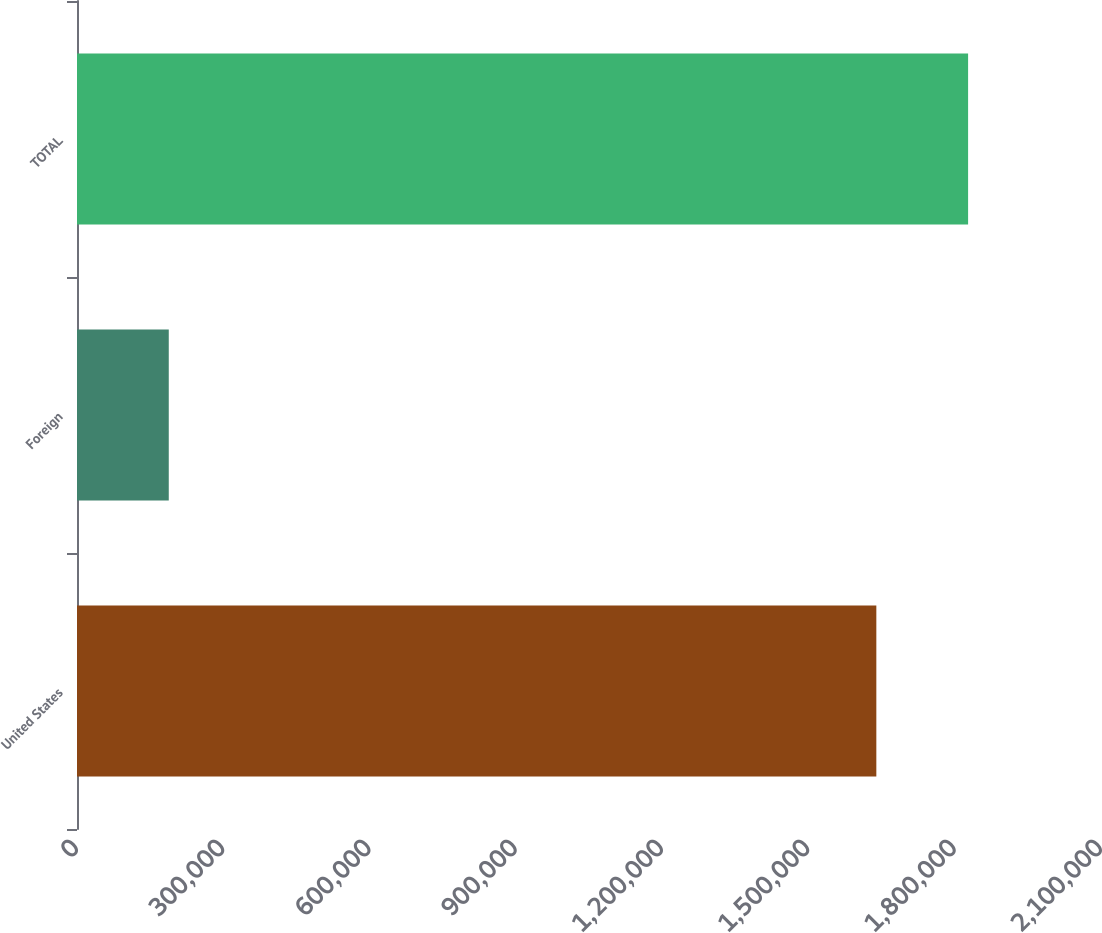Convert chart to OTSL. <chart><loc_0><loc_0><loc_500><loc_500><bar_chart><fcel>United States<fcel>Foreign<fcel>TOTAL<nl><fcel>1.63926e+06<fcel>188196<fcel>1.82745e+06<nl></chart> 